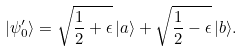<formula> <loc_0><loc_0><loc_500><loc_500>| \psi _ { 0 } ^ { \prime } \rangle = \sqrt { \frac { 1 } { 2 } + \epsilon } \, | a \rangle + \sqrt { \frac { 1 } { 2 } - \epsilon } \, | b \rangle .</formula> 